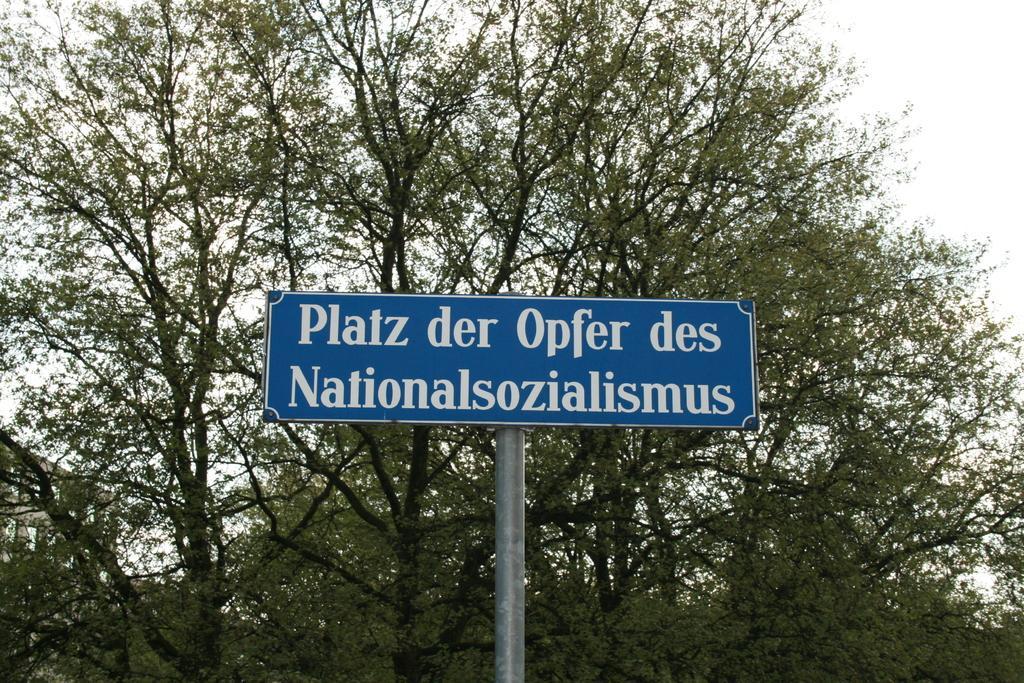In one or two sentences, can you explain what this image depicts? In this image, we can see some trees. There is a board in the middle of the image. 